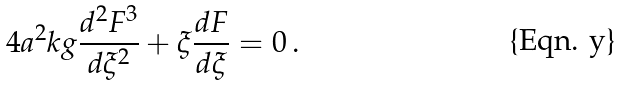<formula> <loc_0><loc_0><loc_500><loc_500>4 a ^ { 2 } k g \frac { d ^ { 2 } F ^ { 3 } } { d \xi ^ { 2 } } + \xi \frac { d F } { d \xi } = 0 \, .</formula> 